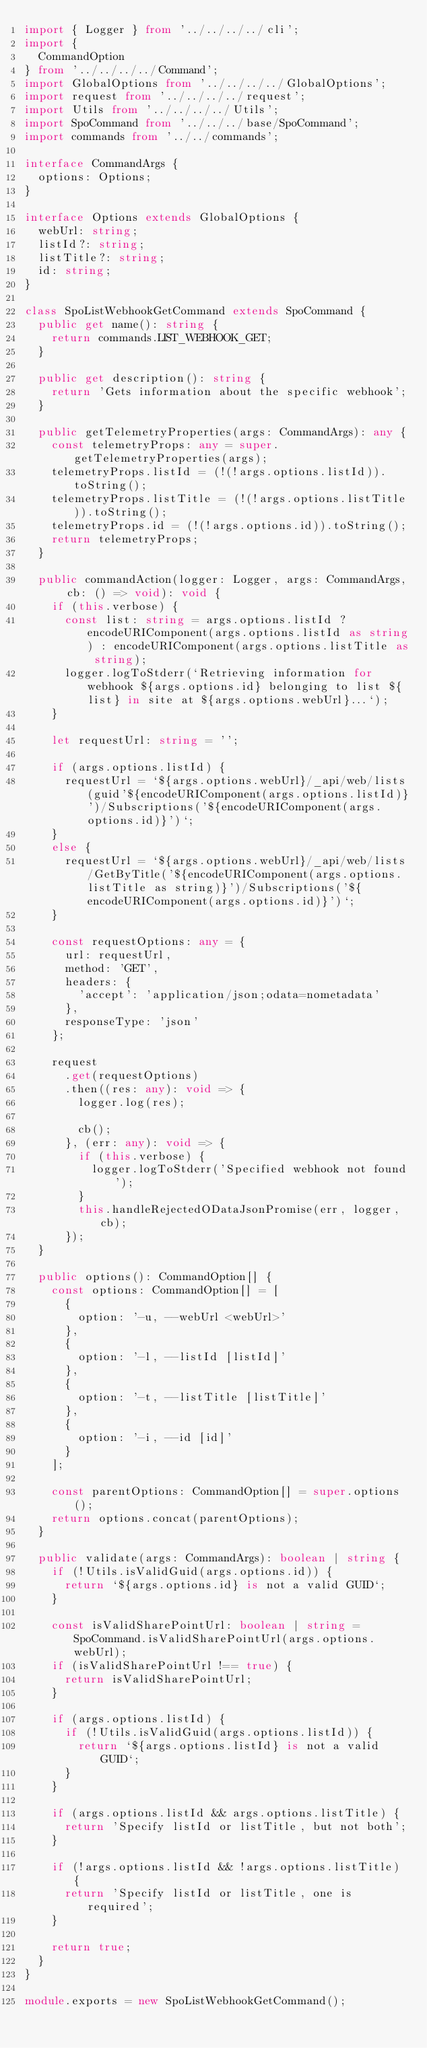Convert code to text. <code><loc_0><loc_0><loc_500><loc_500><_TypeScript_>import { Logger } from '../../../../cli';
import {
  CommandOption
} from '../../../../Command';
import GlobalOptions from '../../../../GlobalOptions';
import request from '../../../../request';
import Utils from '../../../../Utils';
import SpoCommand from '../../../base/SpoCommand';
import commands from '../../commands';

interface CommandArgs {
  options: Options;
}

interface Options extends GlobalOptions {
  webUrl: string;
  listId?: string;
  listTitle?: string;
  id: string;
}

class SpoListWebhookGetCommand extends SpoCommand {
  public get name(): string {
    return commands.LIST_WEBHOOK_GET;
  }

  public get description(): string {
    return 'Gets information about the specific webhook';
  }

  public getTelemetryProperties(args: CommandArgs): any {
    const telemetryProps: any = super.getTelemetryProperties(args);
    telemetryProps.listId = (!(!args.options.listId)).toString();
    telemetryProps.listTitle = (!(!args.options.listTitle)).toString();
    telemetryProps.id = (!(!args.options.id)).toString();
    return telemetryProps;
  }

  public commandAction(logger: Logger, args: CommandArgs, cb: () => void): void {
    if (this.verbose) {
      const list: string = args.options.listId ? encodeURIComponent(args.options.listId as string) : encodeURIComponent(args.options.listTitle as string);
      logger.logToStderr(`Retrieving information for webhook ${args.options.id} belonging to list ${list} in site at ${args.options.webUrl}...`);
    }

    let requestUrl: string = '';

    if (args.options.listId) {
      requestUrl = `${args.options.webUrl}/_api/web/lists(guid'${encodeURIComponent(args.options.listId)}')/Subscriptions('${encodeURIComponent(args.options.id)}')`;
    }
    else {
      requestUrl = `${args.options.webUrl}/_api/web/lists/GetByTitle('${encodeURIComponent(args.options.listTitle as string)}')/Subscriptions('${encodeURIComponent(args.options.id)}')`;
    }

    const requestOptions: any = {
      url: requestUrl,
      method: 'GET',
      headers: {
        'accept': 'application/json;odata=nometadata'
      },
      responseType: 'json'
    };

    request
      .get(requestOptions)
      .then((res: any): void => {
        logger.log(res);

        cb();
      }, (err: any): void => {
        if (this.verbose) {
          logger.logToStderr('Specified webhook not found');
        }
        this.handleRejectedODataJsonPromise(err, logger, cb);
      });
  }

  public options(): CommandOption[] {
    const options: CommandOption[] = [
      {
        option: '-u, --webUrl <webUrl>'
      },
      {
        option: '-l, --listId [listId]'
      },
      {
        option: '-t, --listTitle [listTitle]'
      },
      {
        option: '-i, --id [id]'
      }
    ];

    const parentOptions: CommandOption[] = super.options();
    return options.concat(parentOptions);
  }

  public validate(args: CommandArgs): boolean | string {
    if (!Utils.isValidGuid(args.options.id)) {
      return `${args.options.id} is not a valid GUID`;
    }

    const isValidSharePointUrl: boolean | string = SpoCommand.isValidSharePointUrl(args.options.webUrl);
    if (isValidSharePointUrl !== true) {
      return isValidSharePointUrl;
    }

    if (args.options.listId) {
      if (!Utils.isValidGuid(args.options.listId)) {
        return `${args.options.listId} is not a valid GUID`;
      }
    }

    if (args.options.listId && args.options.listTitle) {
      return 'Specify listId or listTitle, but not both';
    }

    if (!args.options.listId && !args.options.listTitle) {
      return 'Specify listId or listTitle, one is required';
    }

    return true;
  }
}

module.exports = new SpoListWebhookGetCommand();</code> 